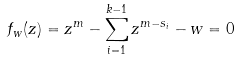Convert formula to latex. <formula><loc_0><loc_0><loc_500><loc_500>f _ { w } ( z ) = z ^ { m } - \sum _ { i = 1 } ^ { k - 1 } z ^ { m - s _ { i } } - w = 0</formula> 